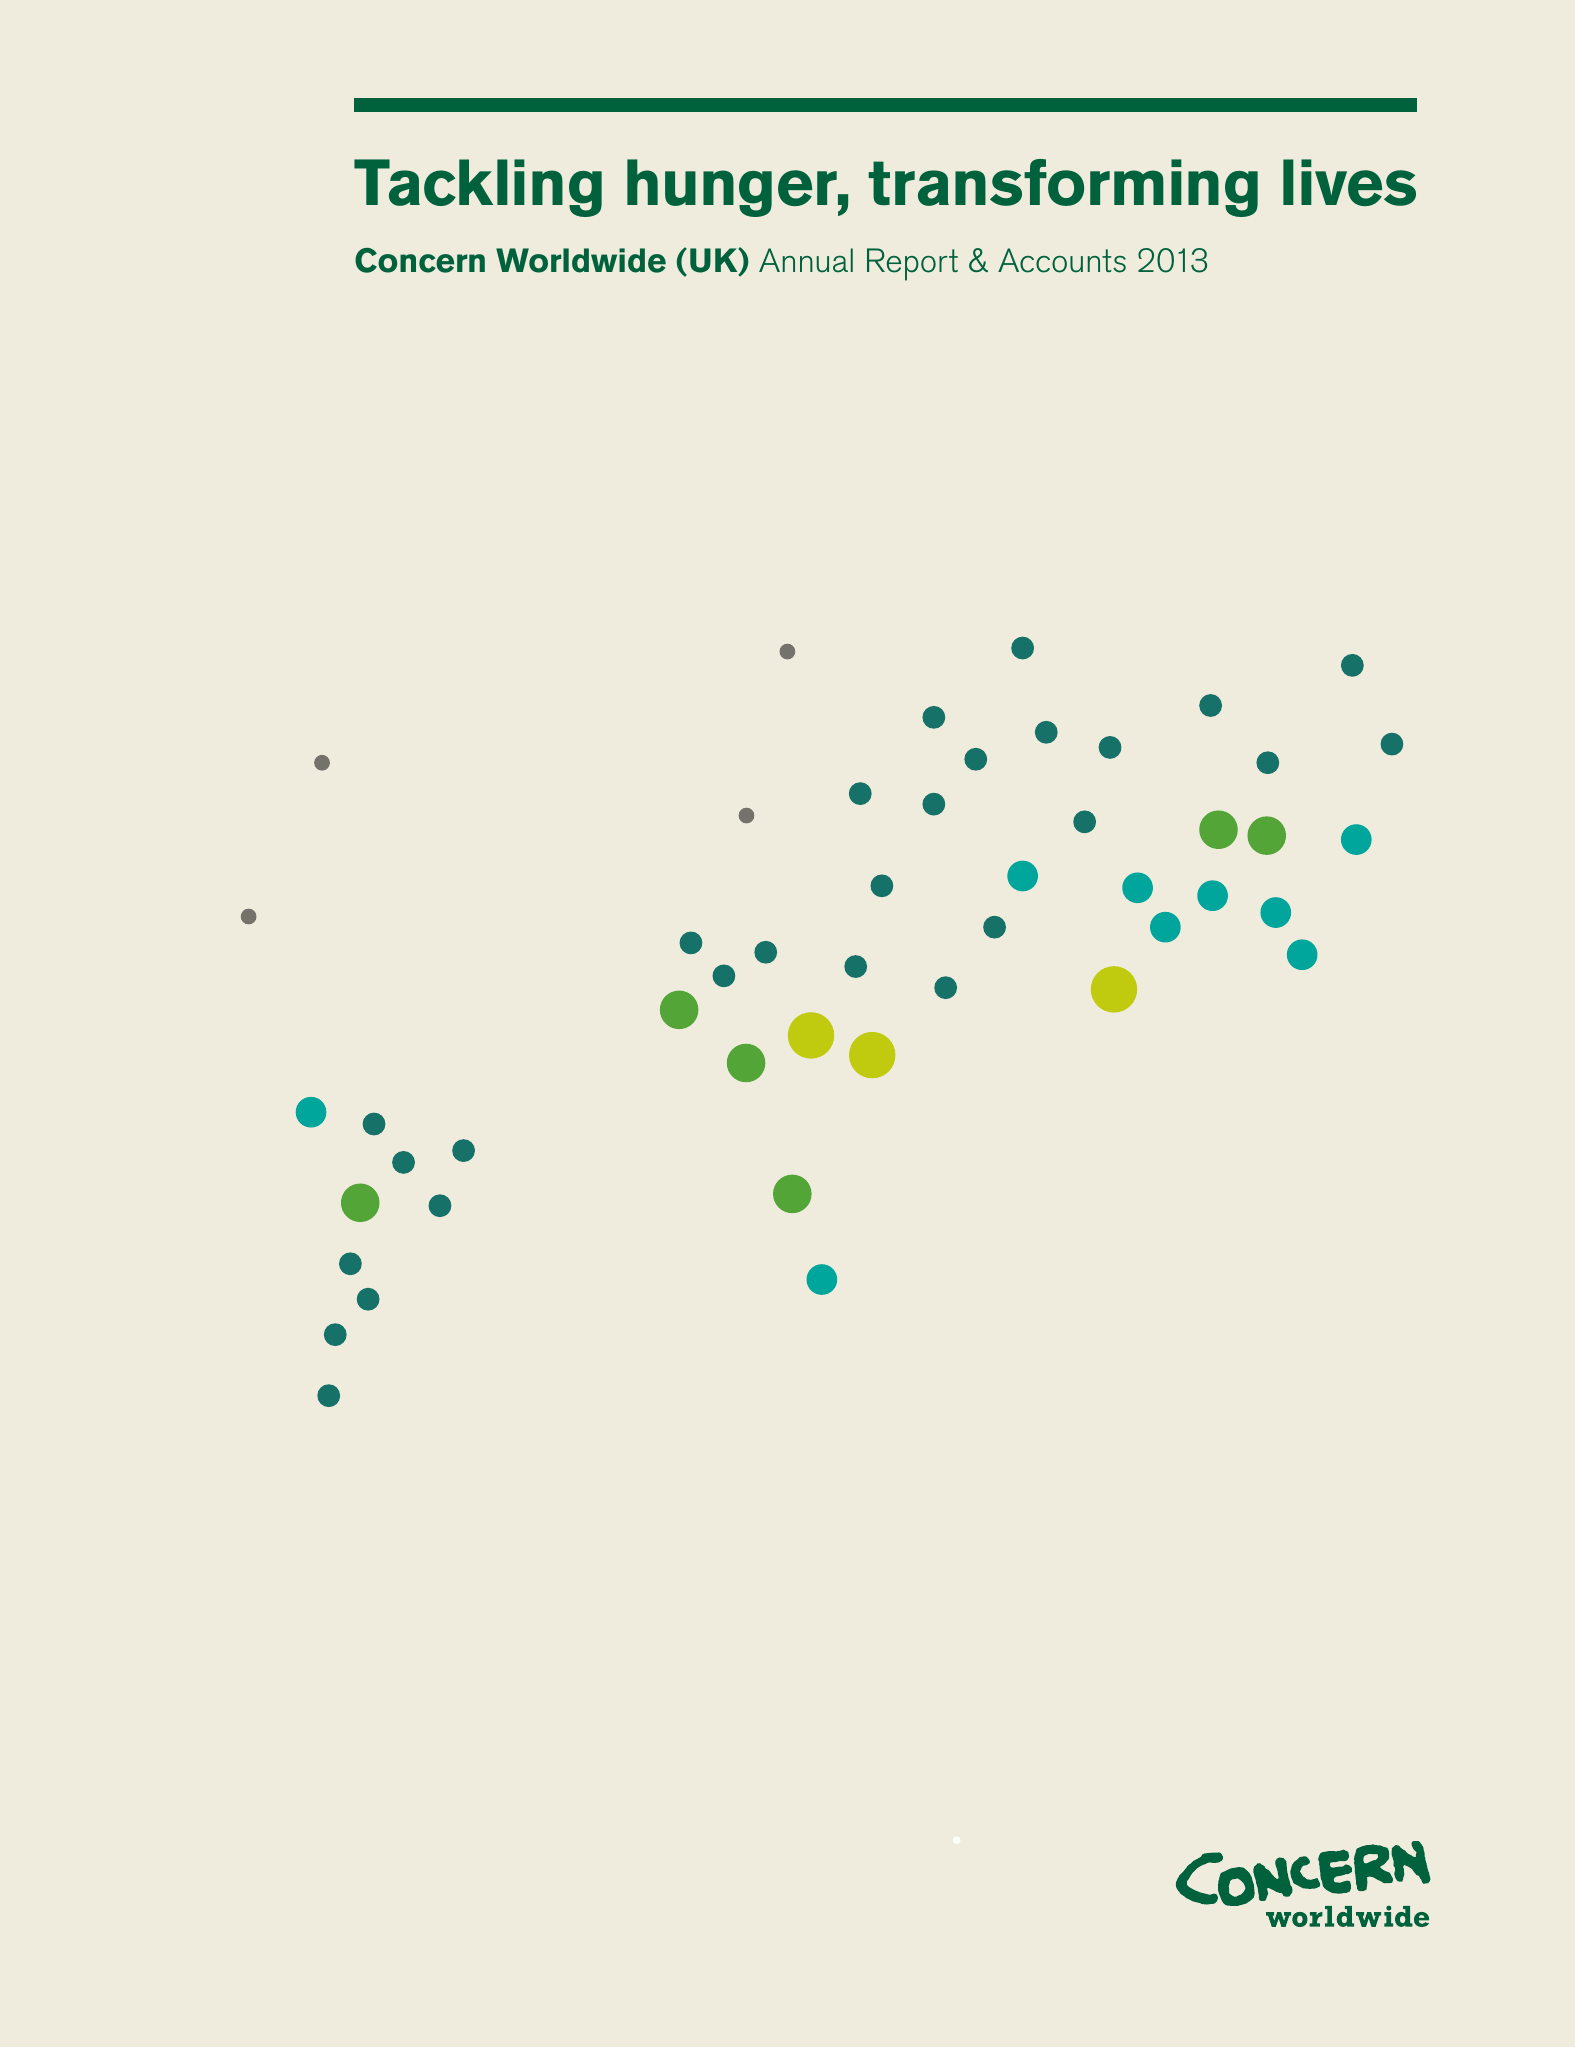What is the value for the address__street_line?
Answer the question using a single word or phrase. YORK ROAD 